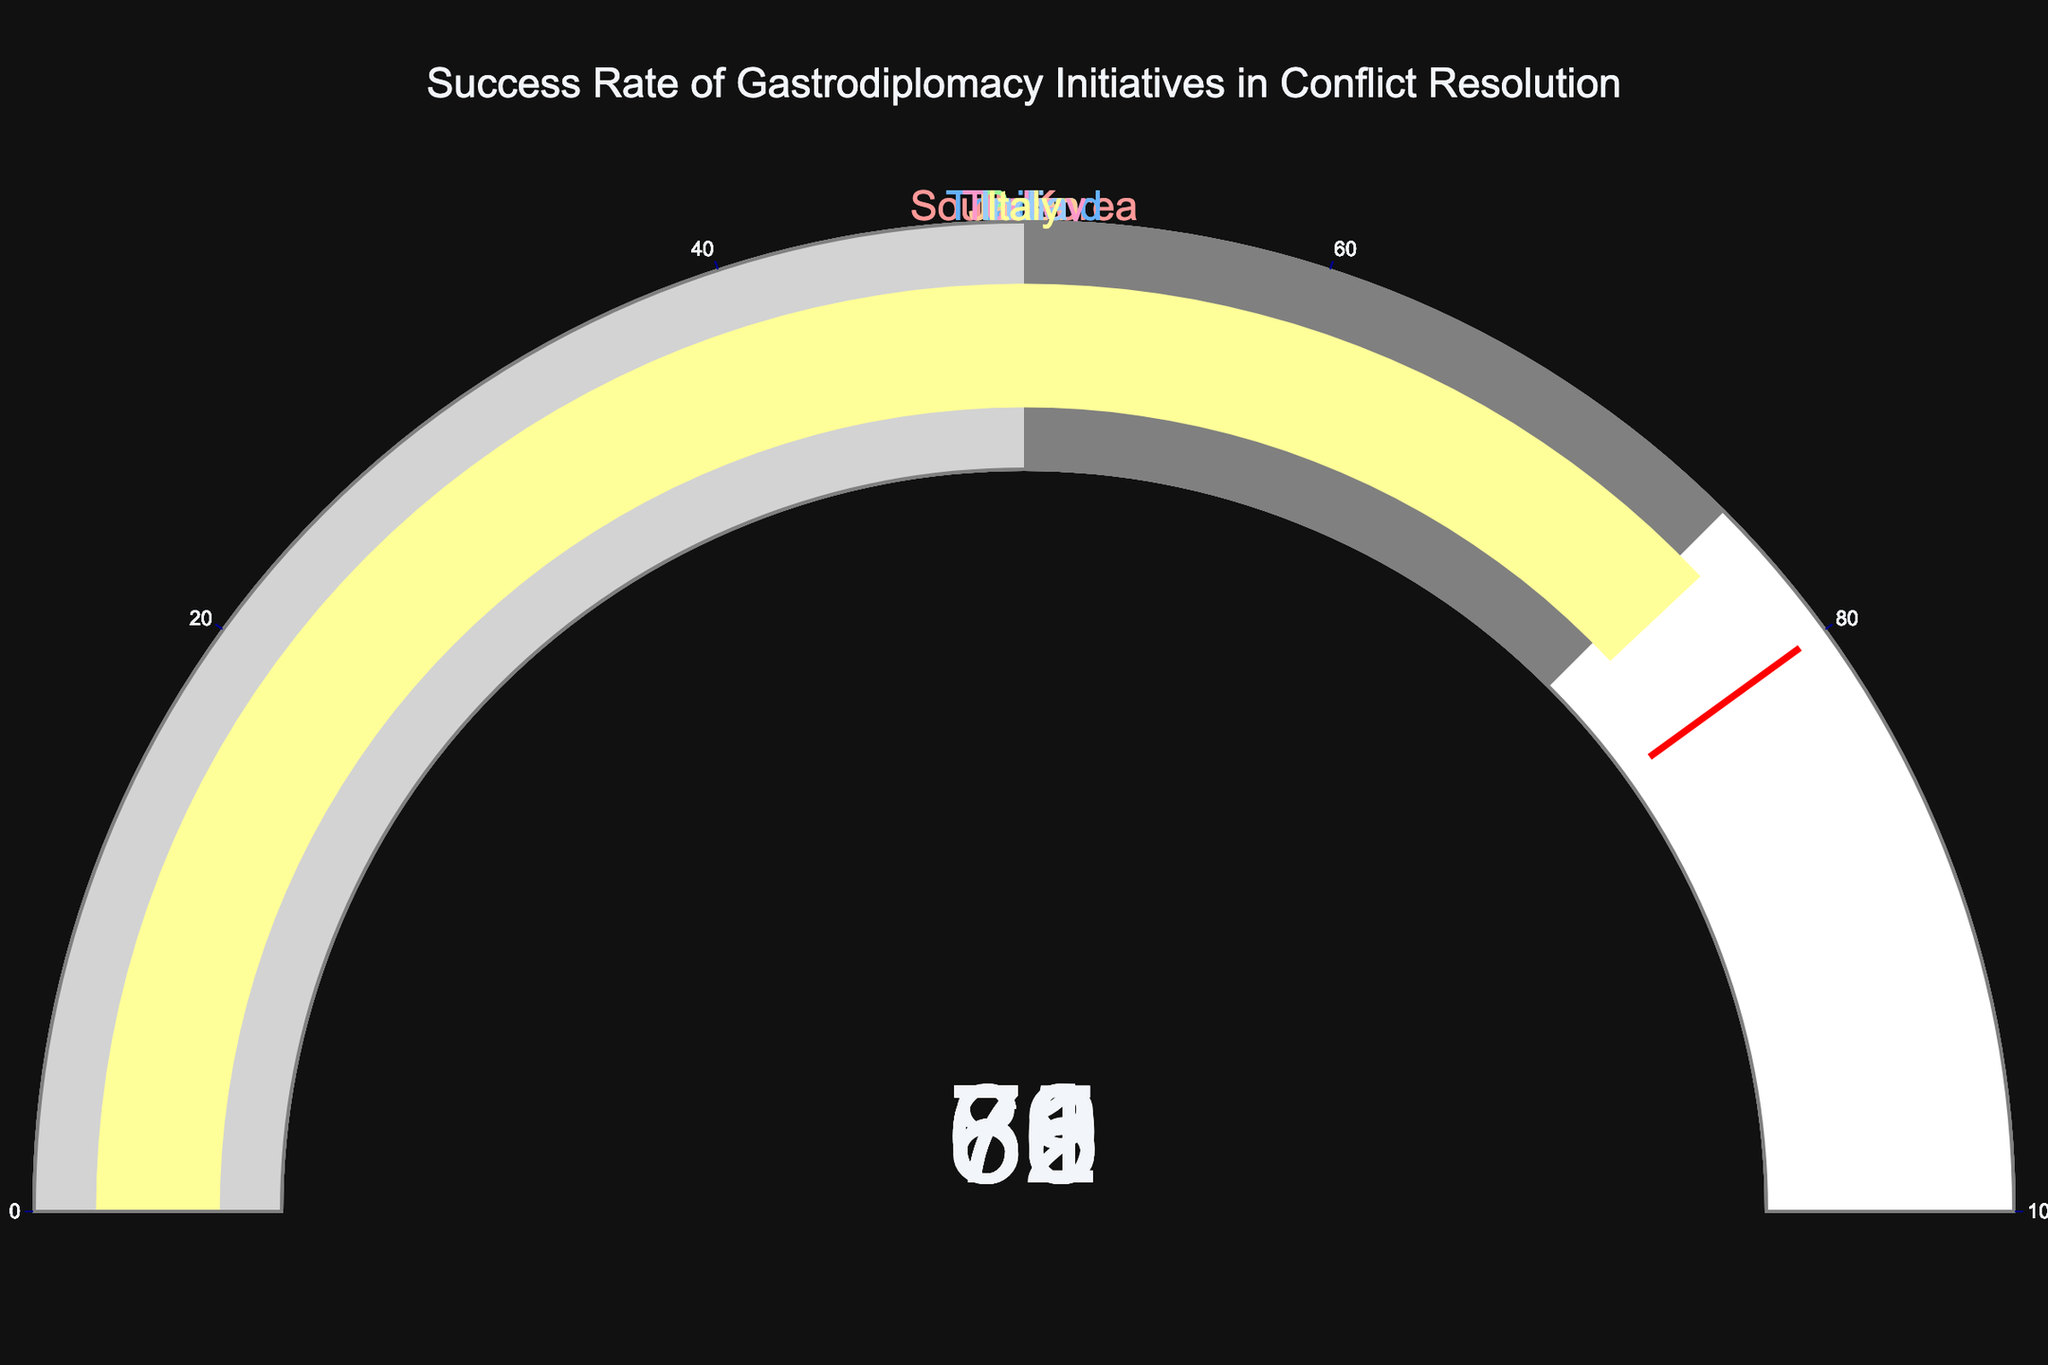what is the title of the figure? The title is located at the top center of the figure, stating the overall purpose or main idea of the chart.
Answer: Success Rate of Gastrodiplomacy Initiatives in Conflict Resolution how many countries are represented in the figure? You can count the number of individual gauges in the figure, each corresponding to a different country.
Answer: 7 which country has the highest success rate in gastrodiplomacy initiatives? You need to look at the values displayed on each gauge and identify the largest one.
Answer: Japan what is the difference in success rate between South Korea and India? Subtract the success rate of India from that of South Korea (78 - 61).
Answer: 17 is there any country that has a success rate above 80? Review the values for each gauge and check if any country exceeds 80.
Answer: Yes, Japan which two countries have the closest success rates? Compare the differences between each pair of countries and identify the smallest difference.
Answer: Peru and Italy what is the average success rate of the countries represented in the figure? Add all success rates together and divide by the number of countries (78 + 65 + 72 + 83 + 69 + 61 + 76) / 7.
Answer: 72 how many countries have a success rate above 70? Count the number of gauges showing values greater than 70.
Answer: 4 which country has a success rate of 69? Look for the country whose gauge displays a success rate of 69.
Answer: Turkey is there a country whose success rate is below 60? Check the values on each gauge to see if any are below 60.
Answer: No 